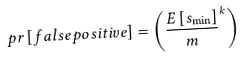<formula> <loc_0><loc_0><loc_500><loc_500>p r \left [ f a l s e p o s i t i v e \right ] = \left ( \frac { E \left [ s _ { \min } \right ] } { m } ^ { k } \right )</formula> 